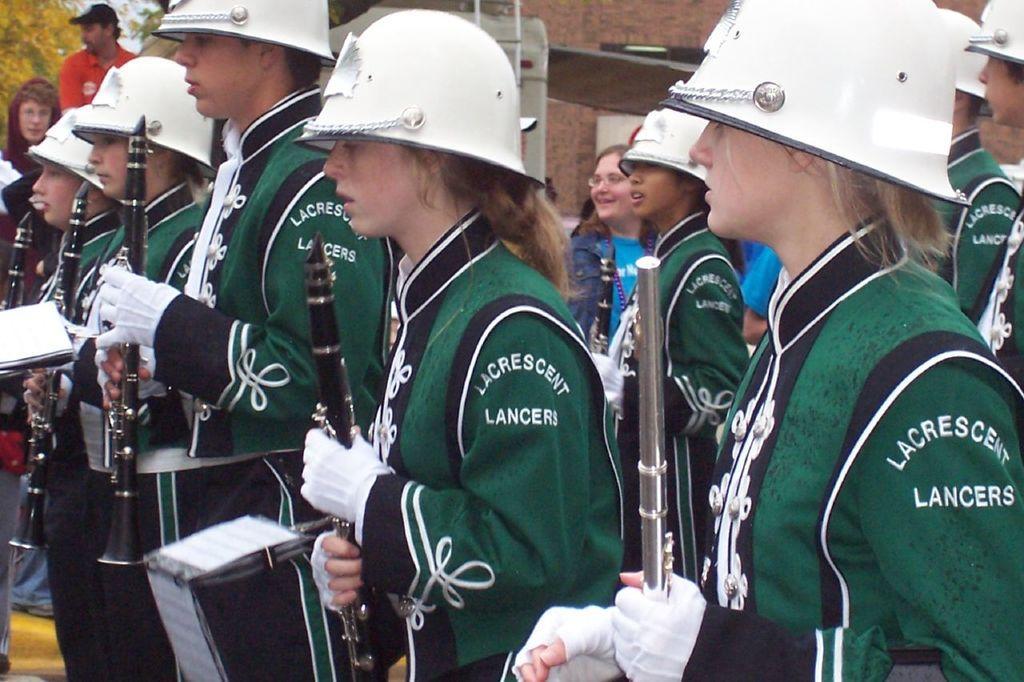Can you describe this image briefly? In this image we can see girls and boys are standing. They are wearing uniforms, helmets and holding musical instruments in their hands. At the top of the image, we can see a wall and an object. We can see a tree and people in the left top of the image. In the middle of the image, we can see a woman. 